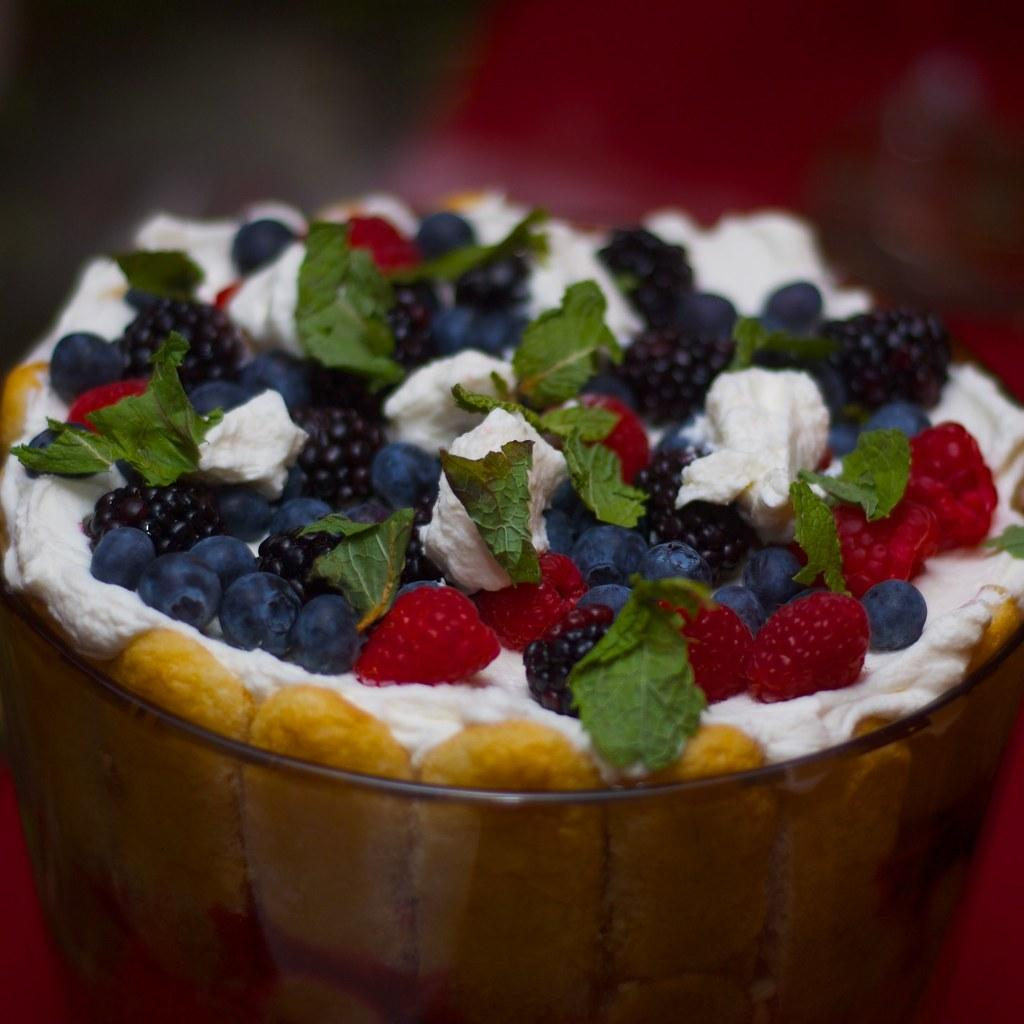What type of landscape is shown in the image? The image depicts a desert. What is used to decorate the desert in the image? The desert is decorated with many fruits and cream. Can you see any signs of an argument between the fruits in the image? There is no indication of an argument between the fruits in the image, as fruits do not have the ability to argue. 